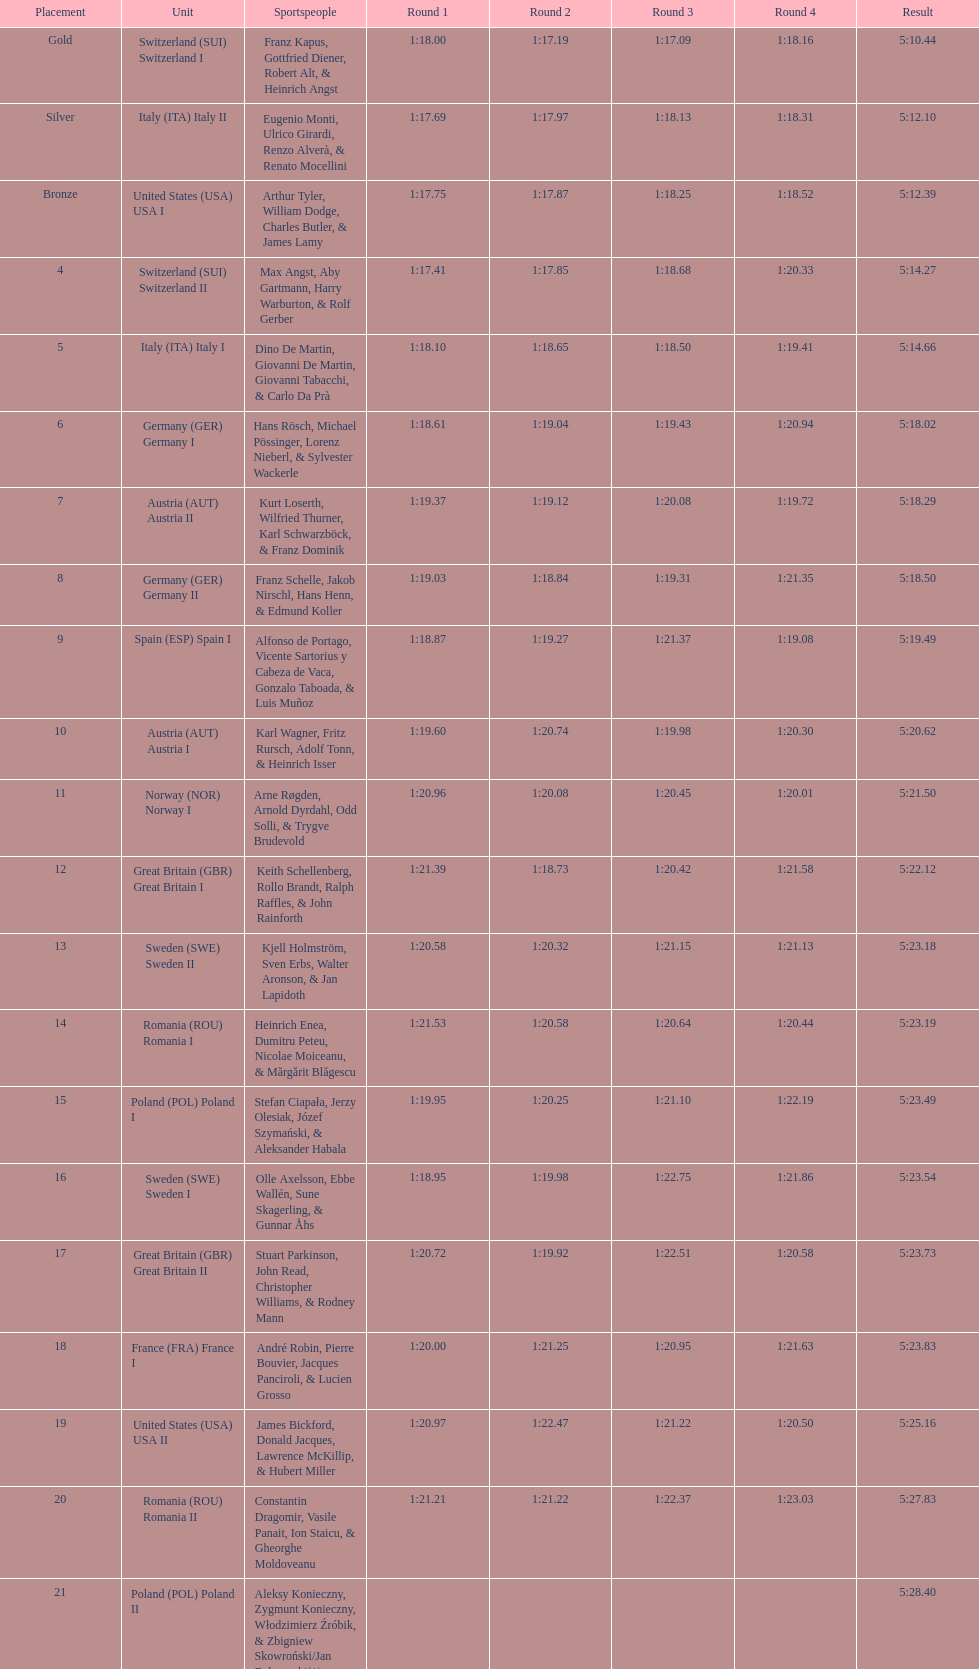How many teams did germany have? 2. 